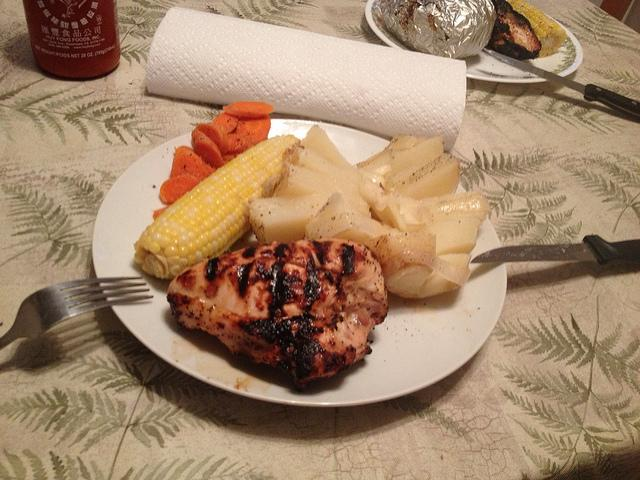What was used to cook the meat and potatoes of the dish?

Choices:
A) stove
B) oven
C) air fryer
D) grill grill 